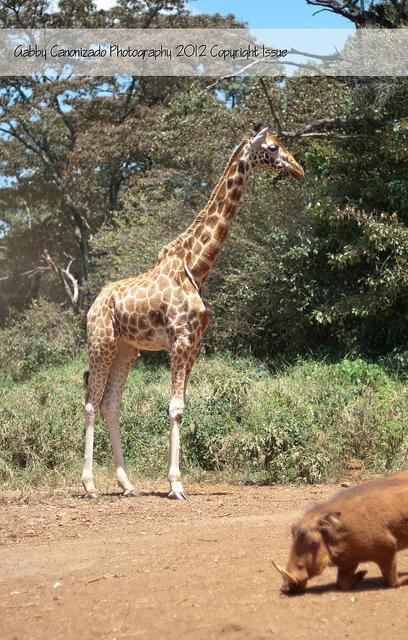What is the giraffe doing near the other animal?
Short answer required. Standing. What is the animal in the bottom right corner?
Write a very short answer. Boar. What kind of animal is this?
Give a very brief answer. Giraffe. What color is the ground?
Concise answer only. Brown. 